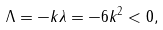Convert formula to latex. <formula><loc_0><loc_0><loc_500><loc_500>\Lambda = - k \lambda = - 6 k ^ { 2 } < 0 ,</formula> 